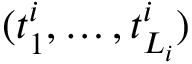Convert formula to latex. <formula><loc_0><loc_0><loc_500><loc_500>( t _ { 1 } ^ { i } , \dots , t _ { L _ { i } } ^ { i } )</formula> 